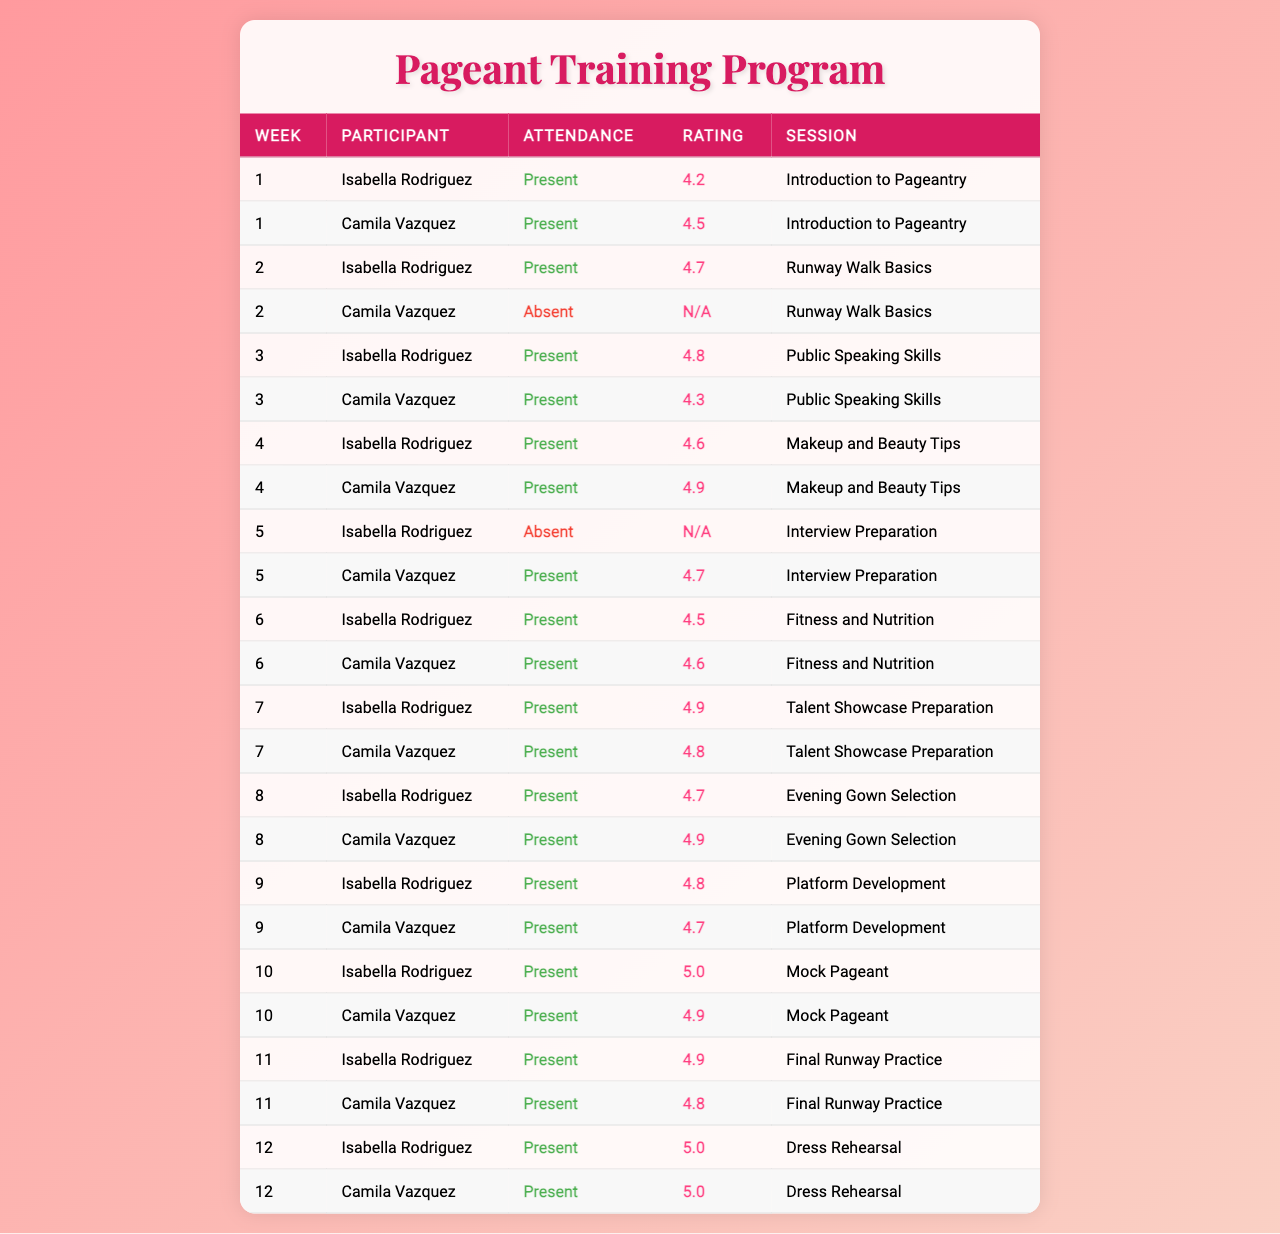What was the highest rating received by Isabella Rodriguez? Looking at the ratings for Isabella Rodriguez, the highest rating is found in week 10 during the "Mock Pageant" session with a score of 5.0.
Answer: 5.0 Did Camila Vazquez attend all sessions? By reviewing the attendance of Camila Vazquez, we notice that she was absent in week 2 during the "Runway Walk Basics" session, indicating she did not attend all sessions.
Answer: No What is the average rating for Camila Vazquez across all sessions? To find the average rating, we first sum the ratings: (4.5 + 4.3 + 4.9 + 4.7 + 4.6 + 4.8 + 4.9 + 4.7 + 4.9 + 4.8 + 5.0) = 52.1. Then, we count the number of sessions attended: 11. Finally, we divide 52.1 by 11, resulting in an average rating of approximately 4.73.
Answer: 4.73 Which week had the highest combined ratings for both participants? We calculate the combined ratings for each week where both participants attended: Week 3: 4.8 + 4.3 = 9.1, Week 4: 4.6 + 4.9 = 9.5, Week 6: 4.5 + 4.6 = 9.1, Week 7: 4.9 + 4.8 = 9.7, Week 8: 4.7 + 4.9 = 9.6, Week 9: 4.8 + 4.7 = 9.5, Week 10: 5.0 + 4.9 = 9.9, Week 11: 4.9 + 4.8 = 9.7, and Week 12: 5.0 + 5.0 = 10.0. The highest combined rating is in Week 12 with a total of 10.0.
Answer: Week 12 Was there any session where both participants received a rating of 5.0? Assessing the ratings, we see that in week 10, both participants received scores of 5.0 during the "Mock Pageant" session, confirming that there was a session with this rating.
Answer: Yes How many sessions did Isabella Rodriguez miss? By reviewing Isabella Rodriguez's attendance, we can see she missed one session: the interview preparation in week 5. Therefore, the total missed sessions are counted as 1.
Answer: 1 Compare the highest rating of each participant. Who had the highest overall rating? The highest rating for Isabella Rodriguez is 5.0 (week 10) and for Camila Vazquez, it's also 5.0 (week 12). They are equal; hence, neither has the highest overall rating against the other.
Answer: They are equal 